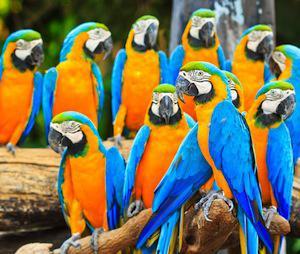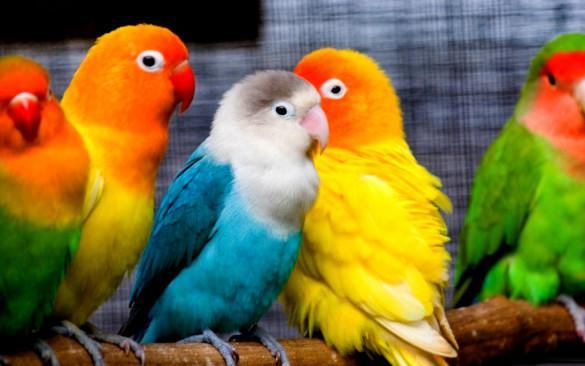The first image is the image on the left, the second image is the image on the right. Examine the images to the left and right. Is the description "One image contains exactly six birds." accurate? Answer yes or no. No. 